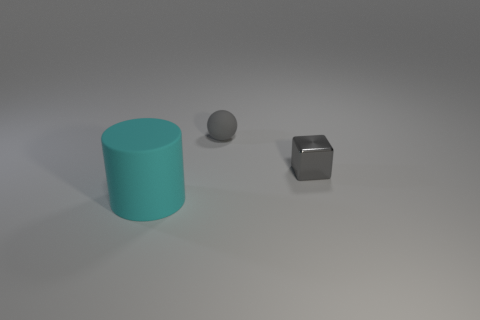Is there any other thing that is the same size as the cyan rubber cylinder?
Your answer should be very brief. No. Is there any other thing that has the same shape as the big matte object?
Your answer should be very brief. No. There is a cylinder left of the gray metallic block; is its size the same as the tiny gray matte ball?
Keep it short and to the point. No. There is a thing that is to the right of the big cyan cylinder and left of the block; what is its size?
Your answer should be compact. Small. What number of other things are there of the same material as the big object
Your answer should be compact. 1. There is a thing right of the ball; how big is it?
Your response must be concise. Small. Do the small metallic block and the matte ball have the same color?
Your answer should be compact. Yes. How many small objects are blue rubber objects or cylinders?
Give a very brief answer. 0. Is there anything else that has the same color as the small cube?
Give a very brief answer. Yes. Are there any things to the left of the small sphere?
Offer a very short reply. Yes. 